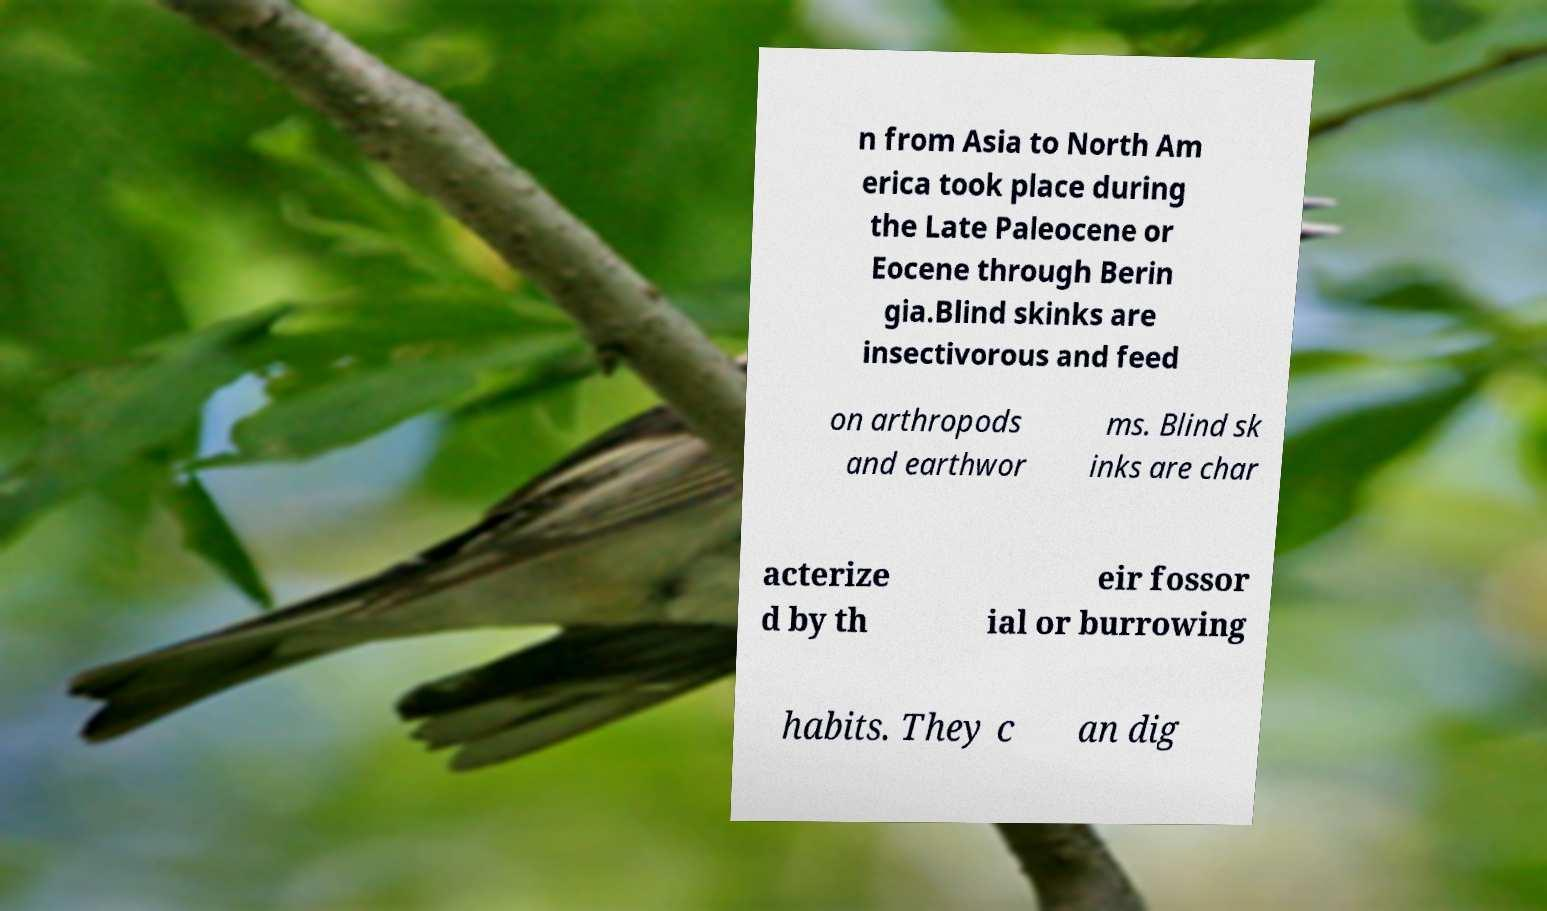Please read and relay the text visible in this image. What does it say? n from Asia to North Am erica took place during the Late Paleocene or Eocene through Berin gia.Blind skinks are insectivorous and feed on arthropods and earthwor ms. Blind sk inks are char acterize d by th eir fossor ial or burrowing habits. They c an dig 